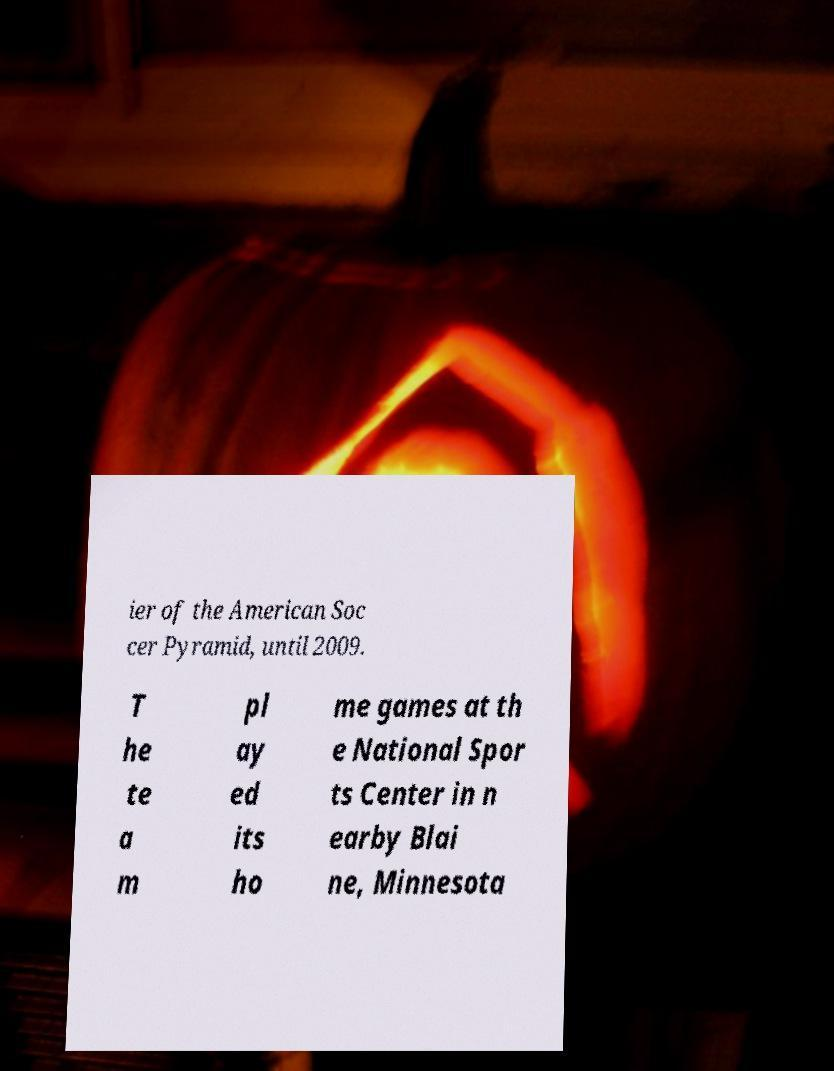I need the written content from this picture converted into text. Can you do that? ier of the American Soc cer Pyramid, until 2009. T he te a m pl ay ed its ho me games at th e National Spor ts Center in n earby Blai ne, Minnesota 